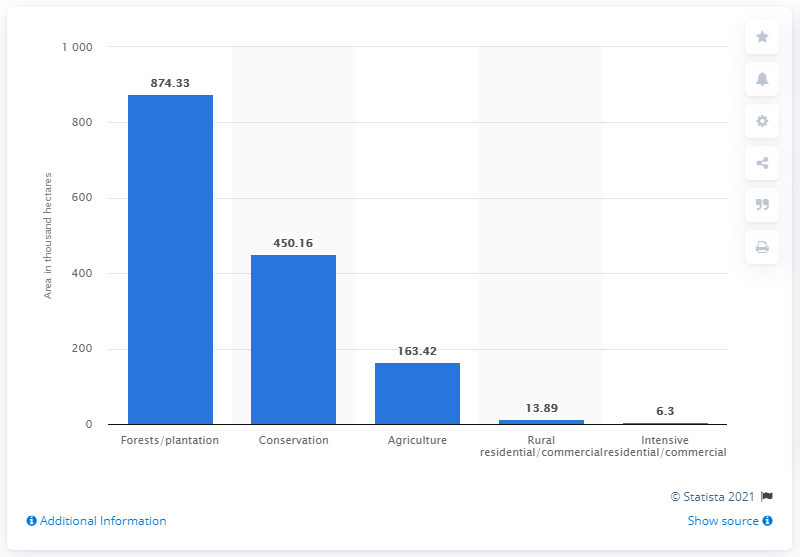Draw attention to some important aspects in this diagram. The area of fires that are not in forests/plantations is 633.77.. The land that has the most data on the graph is forests/plantations. 